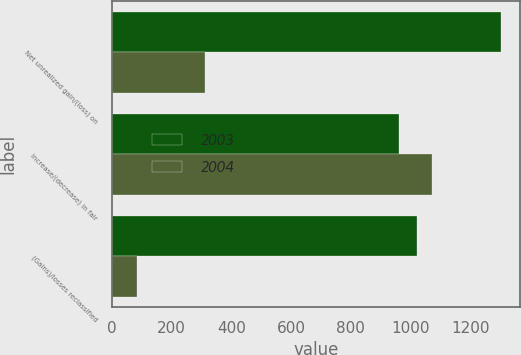Convert chart to OTSL. <chart><loc_0><loc_0><loc_500><loc_500><stacked_bar_chart><ecel><fcel>Net unrealized gain/(loss) on<fcel>Increase/(decrease) in fair<fcel>(Gains)/losses reclassified<nl><fcel>2003<fcel>1302<fcel>961<fcel>1023<nl><fcel>2004<fcel>313<fcel>1072<fcel>83<nl></chart> 